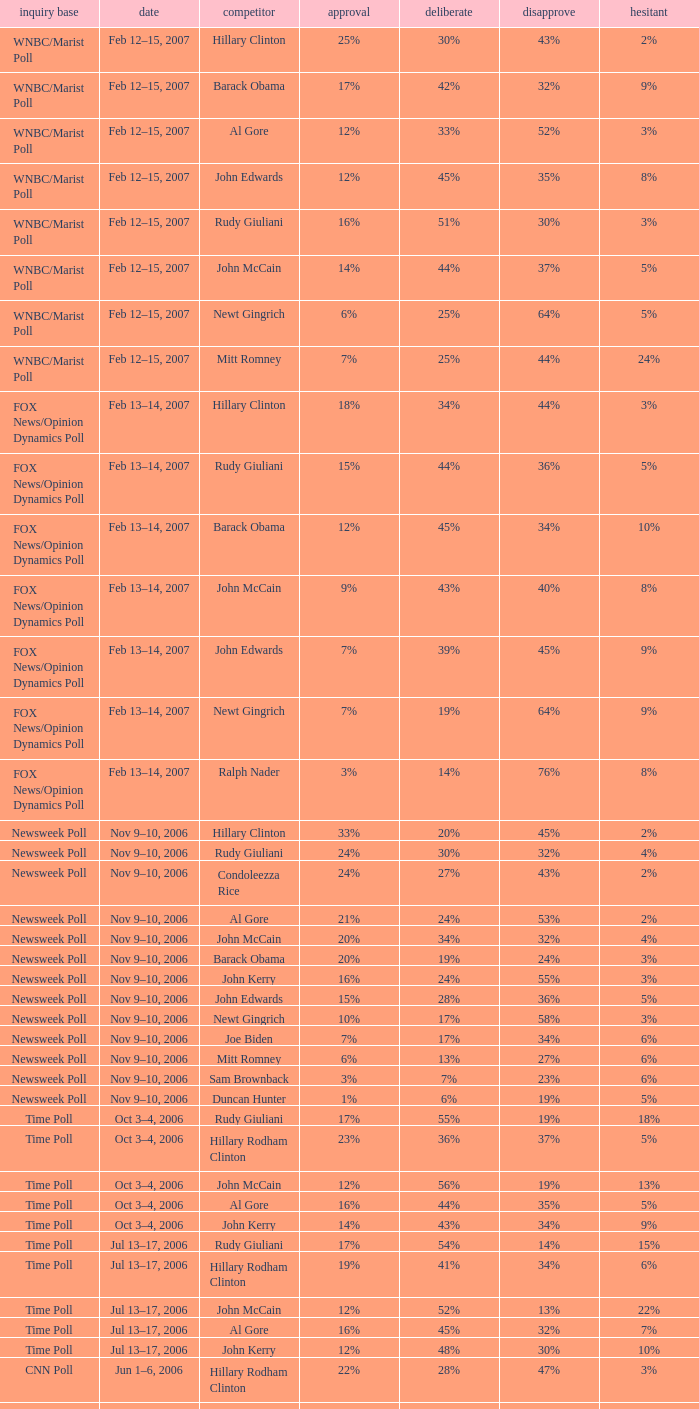What percentage of people said they would consider Rudy Giuliani as a candidate according to the Newsweek poll that showed 32% opposed him? 30%. 